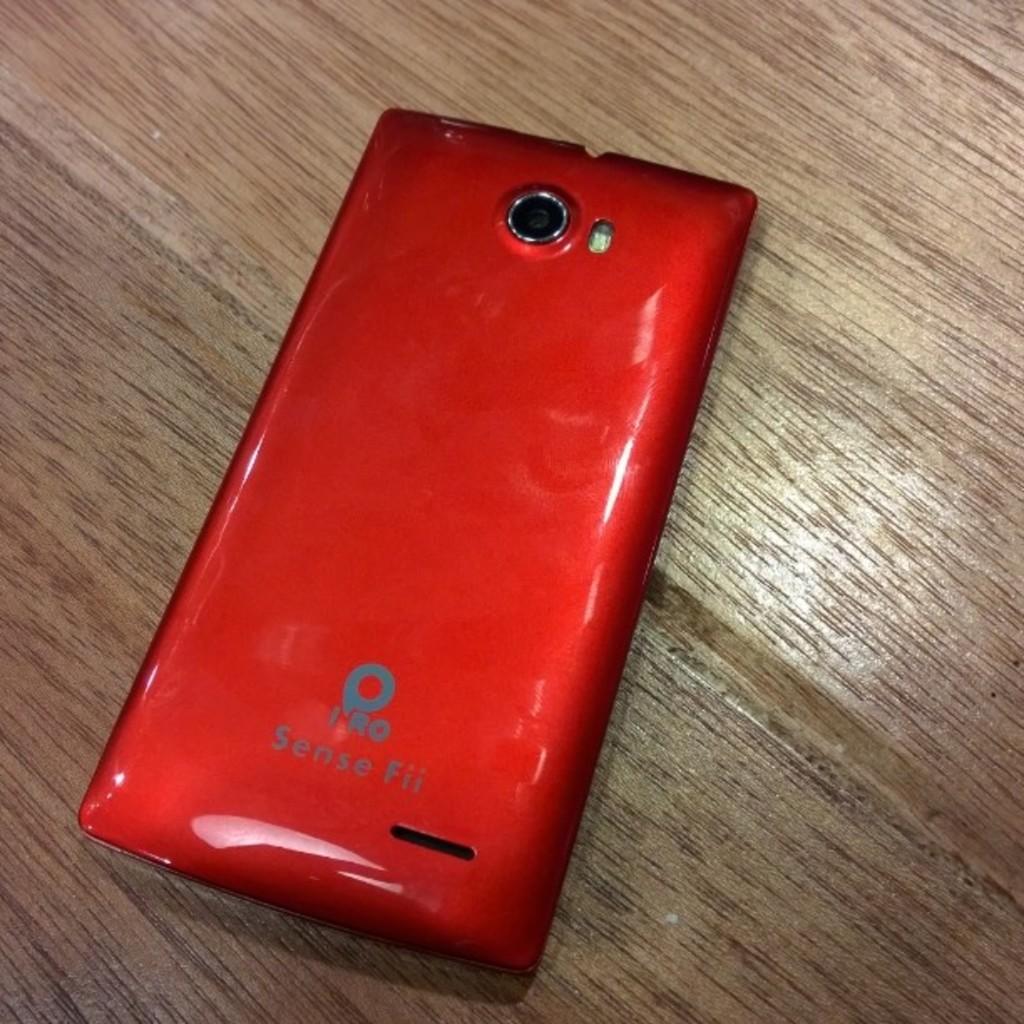What brand is this phone?
Make the answer very short. Iro. 